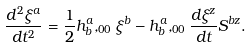Convert formula to latex. <formula><loc_0><loc_0><loc_500><loc_500>\frac { d ^ { 2 } \xi ^ { a } } { d t ^ { 2 } } = \frac { 1 } { 2 } h _ { b } ^ { a } , _ { 0 0 } \xi ^ { b } - h _ { b } ^ { a } , _ { 0 0 } \frac { d \xi ^ { z } } { d t } S ^ { b z } .</formula> 